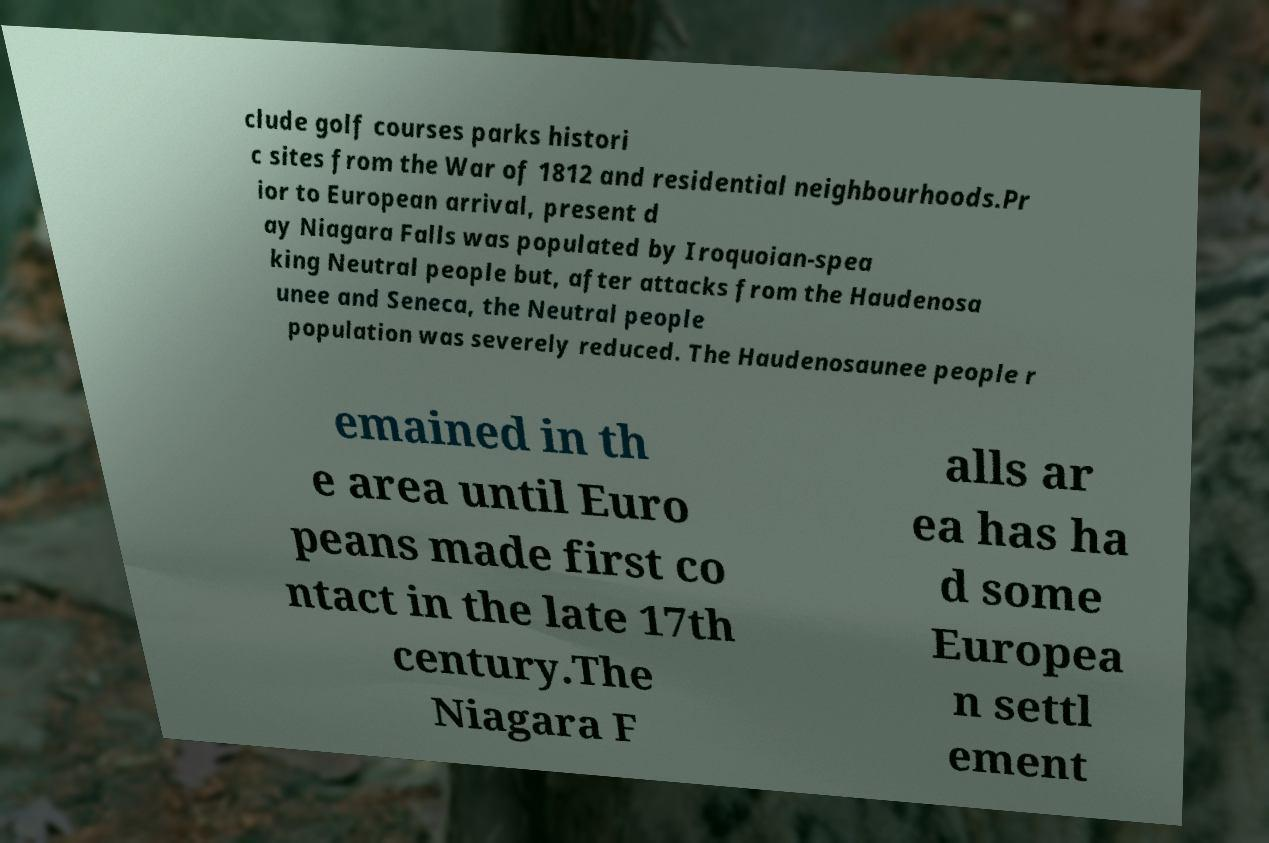There's text embedded in this image that I need extracted. Can you transcribe it verbatim? clude golf courses parks histori c sites from the War of 1812 and residential neighbourhoods.Pr ior to European arrival, present d ay Niagara Falls was populated by Iroquoian-spea king Neutral people but, after attacks from the Haudenosa unee and Seneca, the Neutral people population was severely reduced. The Haudenosaunee people r emained in th e area until Euro peans made first co ntact in the late 17th century.The Niagara F alls ar ea has ha d some Europea n settl ement 